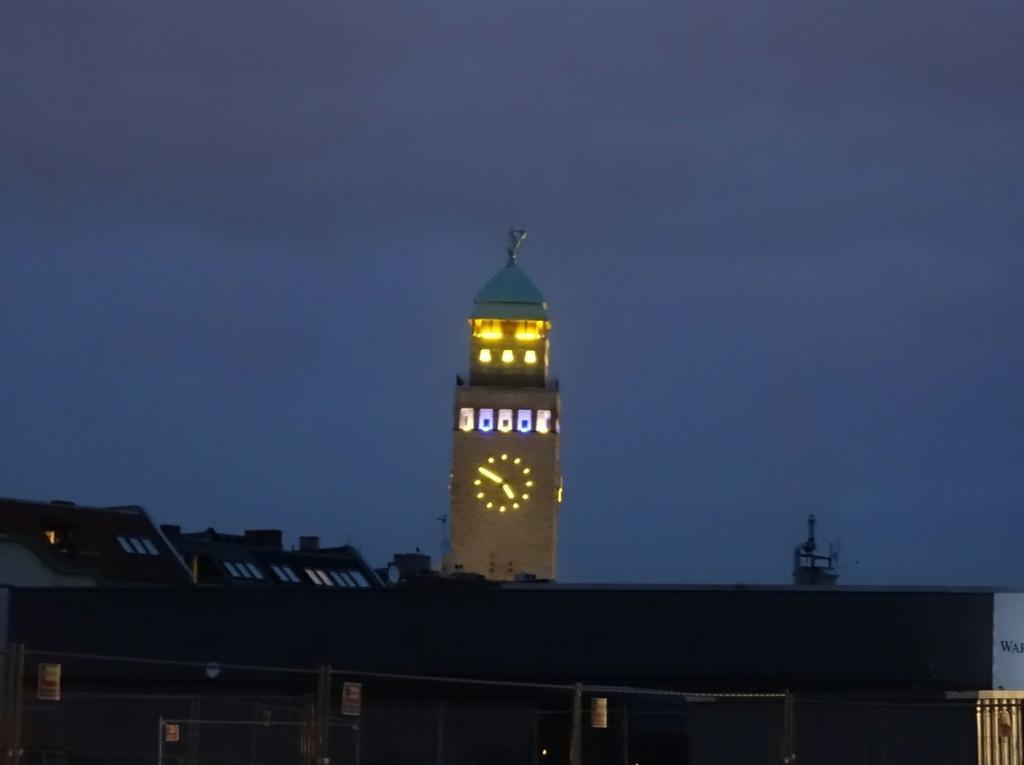Can you describe this image briefly? In this picture there are buildings and there is a clock on the tower. In the foreground it looks like a fence and there are boards. At the top there is sky. On the right side of the image it looks like a hoarding and there is text on the hoarding. 